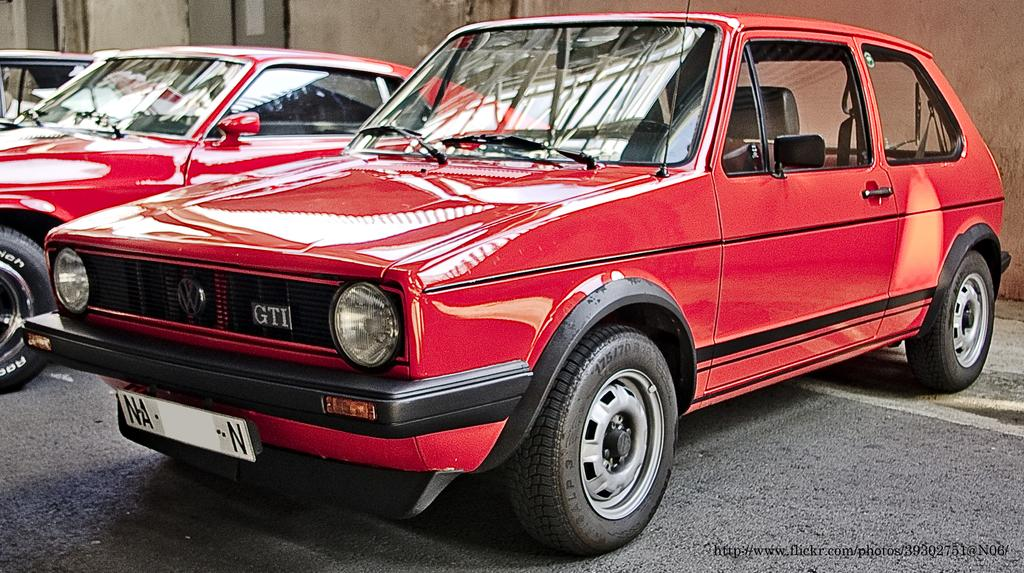Provide a one-sentence caption for the provided image. A classic red VW GTI golf is parked next to other classic cars. 